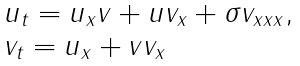Convert formula to latex. <formula><loc_0><loc_0><loc_500><loc_500>\begin{array} { l } u _ { t } = u _ { x } v + u v _ { x } + \sigma v _ { x x x } , \\ v _ { t } = u _ { x } + v v _ { x } \end{array}</formula> 